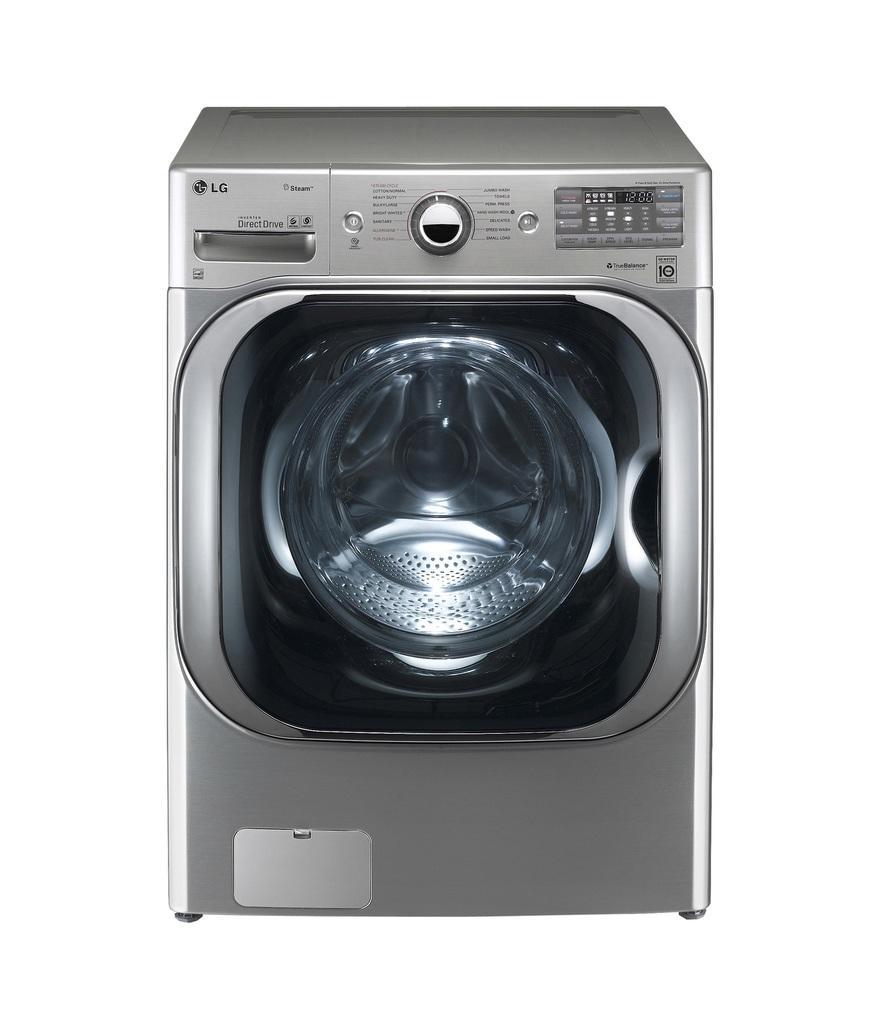Could you give a brief overview of what you see in this image? In the image there is a washing machine of LG company. 